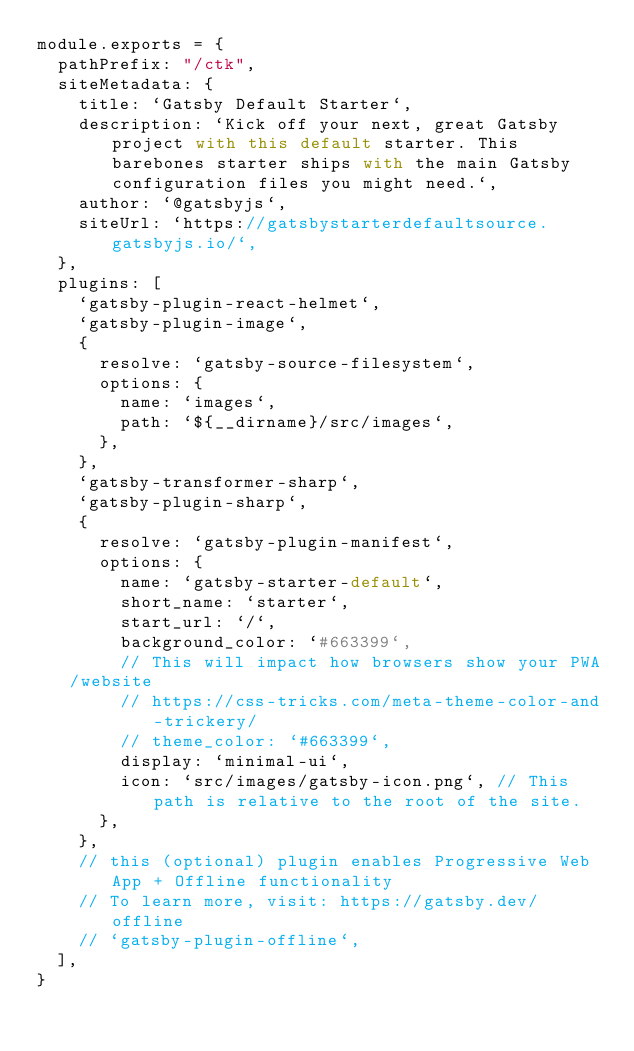Convert code to text. <code><loc_0><loc_0><loc_500><loc_500><_JavaScript_>module.exports = {
  pathPrefix: "/ctk",
  siteMetadata: {
    title: `Gatsby Default Starter`,
    description: `Kick off your next, great Gatsby project with this default starter. This barebones starter ships with the main Gatsby configuration files you might need.`,
    author: `@gatsbyjs`,
    siteUrl: `https://gatsbystarterdefaultsource.gatsbyjs.io/`,
  },
  plugins: [
    `gatsby-plugin-react-helmet`,
    `gatsby-plugin-image`,
    {
      resolve: `gatsby-source-filesystem`,
      options: {
        name: `images`,
        path: `${__dirname}/src/images`,
      },
    },
    `gatsby-transformer-sharp`,
    `gatsby-plugin-sharp`,
    {
      resolve: `gatsby-plugin-manifest`,
      options: {
        name: `gatsby-starter-default`,
        short_name: `starter`,
        start_url: `/`,
        background_color: `#663399`,
        // This will impact how browsers show your PWA/website
        // https://css-tricks.com/meta-theme-color-and-trickery/
        // theme_color: `#663399`,
        display: `minimal-ui`,
        icon: `src/images/gatsby-icon.png`, // This path is relative to the root of the site.
      },
    },
    // this (optional) plugin enables Progressive Web App + Offline functionality
    // To learn more, visit: https://gatsby.dev/offline
    // `gatsby-plugin-offline`,
  ],
}
</code> 